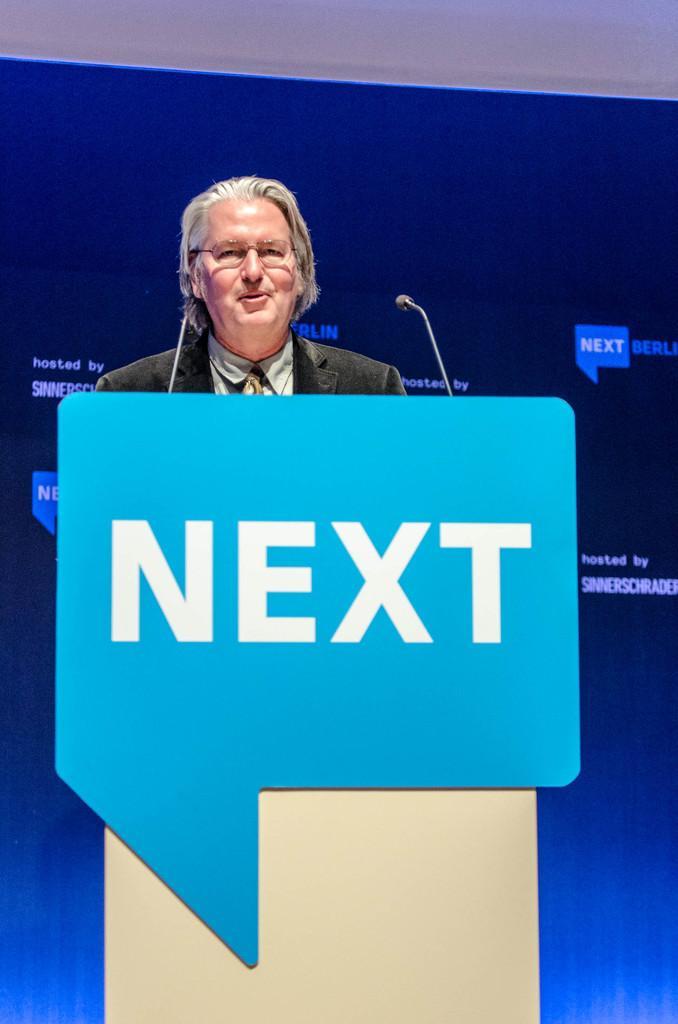How would you summarize this image in a sentence or two? In this image there is a person standing in front of the table and there is a board with some text and there are mic´s. In the background there is a banner with some text. 